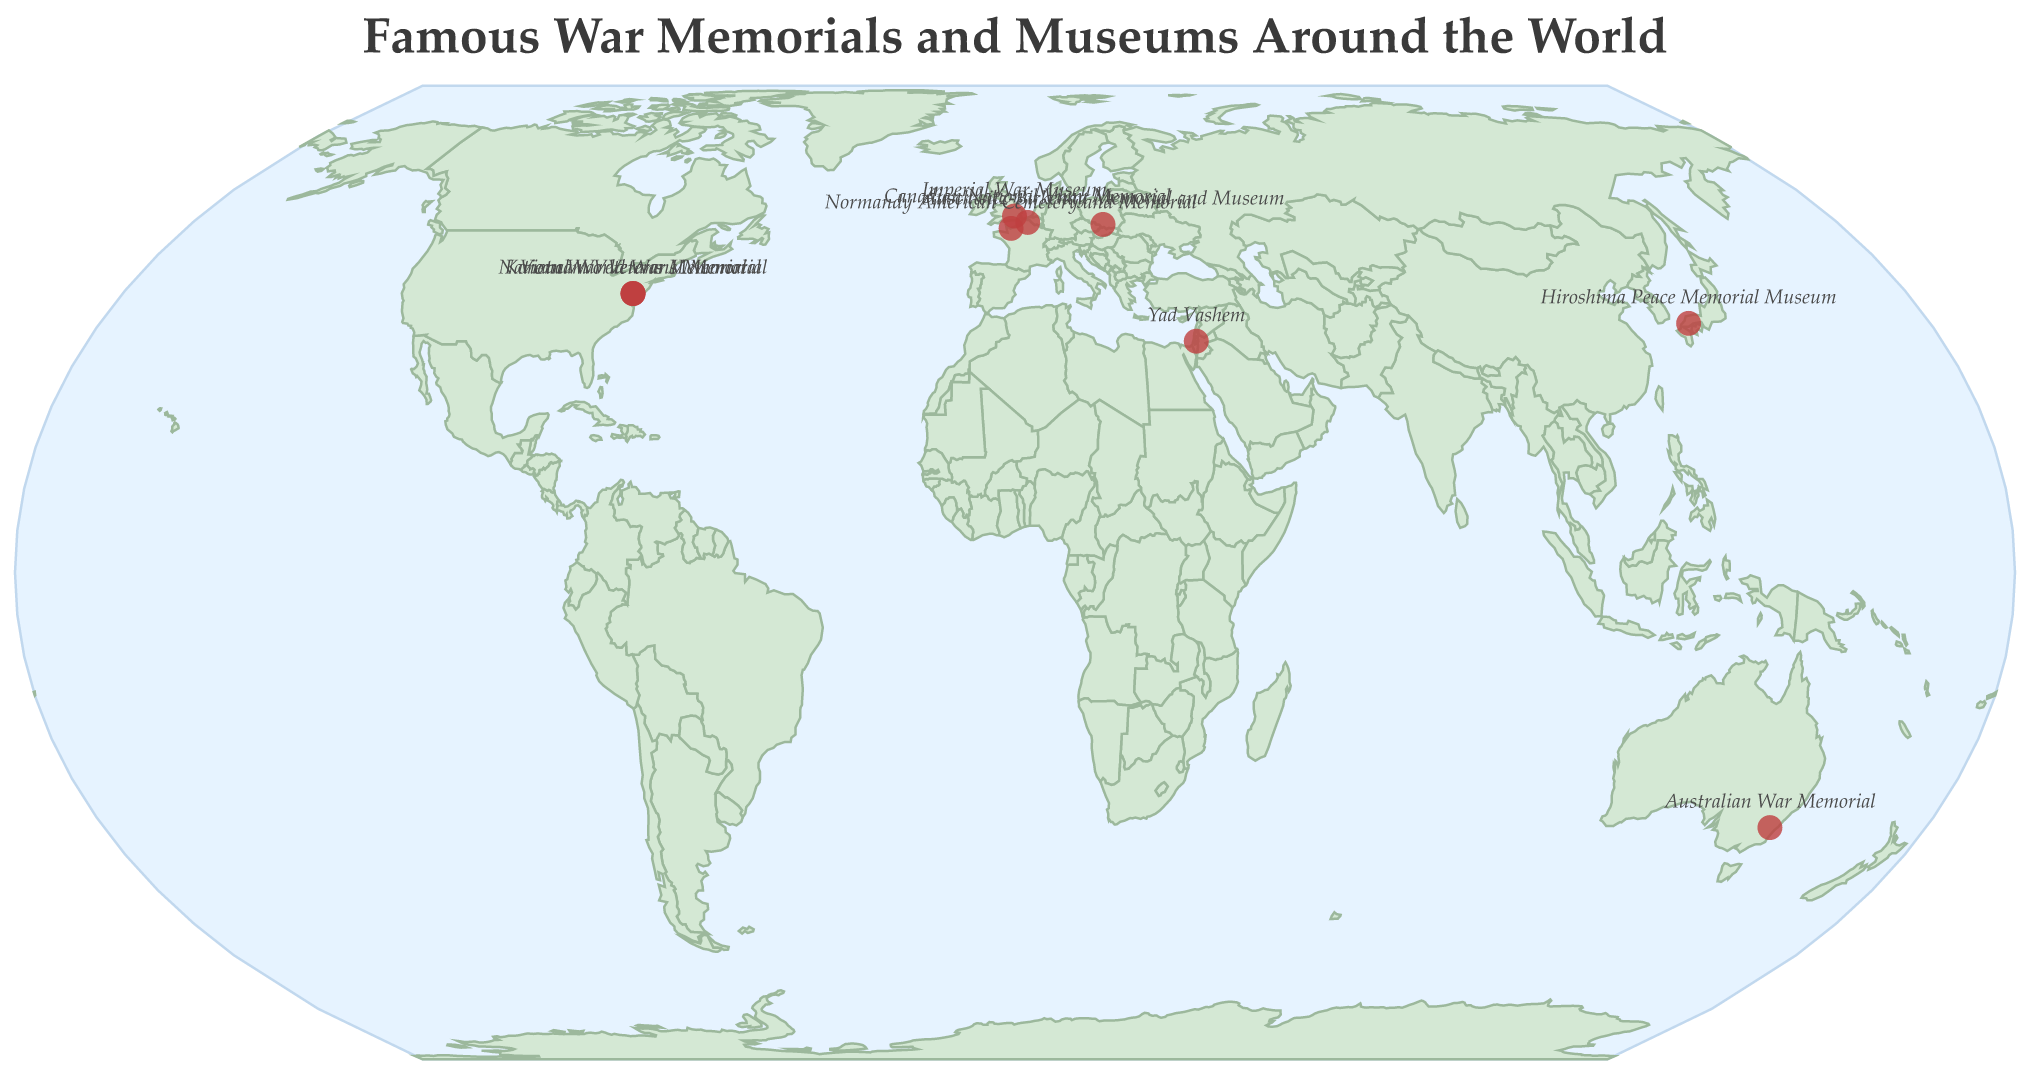What is the title of the plot? The plot's title is usually located at the top and in this case, it reads "Famous War Memorials and Museums Around the World".
Answer: Famous War Memorials and Museums Around the World Where is the Imperial War Museum located? The tooltip provides location information when you hover over a data point. The Imperial War Museum is listed with the coordinates for London.
Answer: London How many war memorials or museums are depicted in Washington D.C.? By visually inspecting the map, we see that there are three red circles clustered around Washington D.C. Each circle represents a different memorial: National World War II Memorial, Vietnam Veterans Memorial, and Korean War Veterans Memorial.
Answer: Three Which memorial is dedicated to Holocaust remembrance? Hovering over the markers, we find that Yad Vashem in Jerusalem and Auschwitz-Birkenau Memorial and Museum are dedicated to Holocaust remembrance.
Answer: Yad Vashem and Auschwitz-Birkenau Memorial and Museum Which two memorials are located in France? By identifying markers on the map of France, we see two memorials: Normandy American Cemetery and Memorial, and Canadian National Vimy Memorial.
Answer: Normandy American Cemetery and Memorial and Canadian National Vimy Memorial What is represented by the red circles on the map? The red circles on the map represent the locations of famous war memorials and museums around the world.
Answer: Locations of famous war memorials and museums How does the location of Yad Vashem compare to that of the Hiroshima Peace Memorial Museum? Yad Vashem is located in Jerusalem, Israel (31.7741, 35.1749), while the Hiroshima Peace Memorial Museum is located in Hiroshima, Japan (34.3955, 132.4536). By comparing their positions on the map, Yad Vashem is situated in the Middle East, whereas Hiroshima Peace Memorial Museum is in East Asia.
Answer: Yad Vashem is in the Middle East and Hiroshima Peace Memorial Museum is in East Asia Which is the southernmost war memorial or museum depicted in the figure? By looking at the latitudes of all locations, we observe that the Australian War Memorial (-35.2810) in Canberra, Australia, is the southernmost point.
Answer: Australian War Memorial How many war memorials or museums are located in Europe according to the figure? Visually inspecting the European continent on the map, we can count four markers representing the Imperial War Museum (London), Normandy American Cemetery and Memorial (France), Canadian National Vimy Memorial (France), and Auschwitz-Birkenau Memorial and Museum (Poland).
Answer: Four 